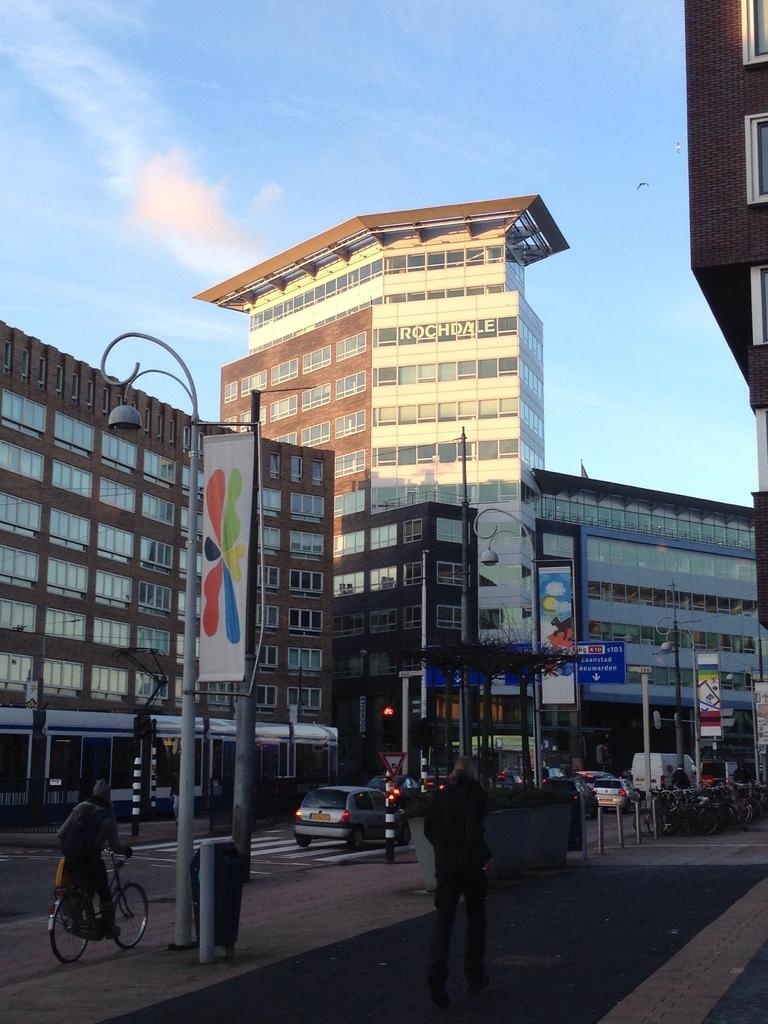What structures can be seen in the image? There are poles in the image. What is happening on the road in the image? There are cars and people on the road in the image. What type of structures are located beside the road? There are buildings beside the road in the image. What is the slope of the trick condition in the image? There is no trick or slope mentioned in the image; it features poles, cars, people, and buildings. 